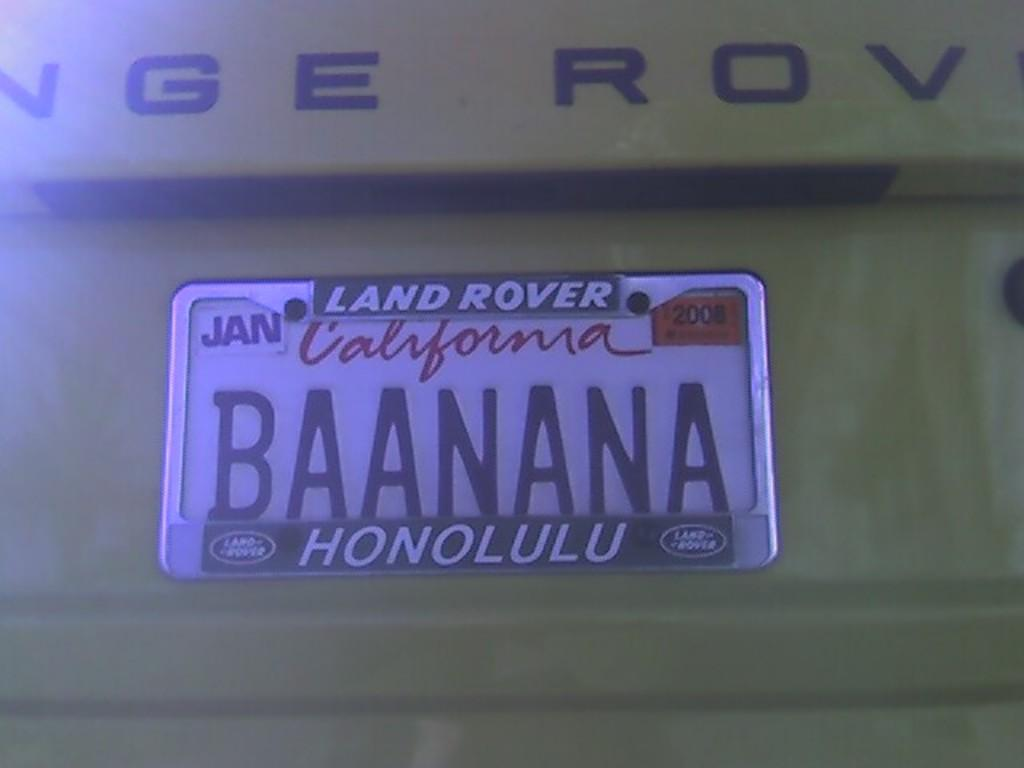<image>
Describe the image concisely. A California license plate that says Land Rover on the plate itself. 